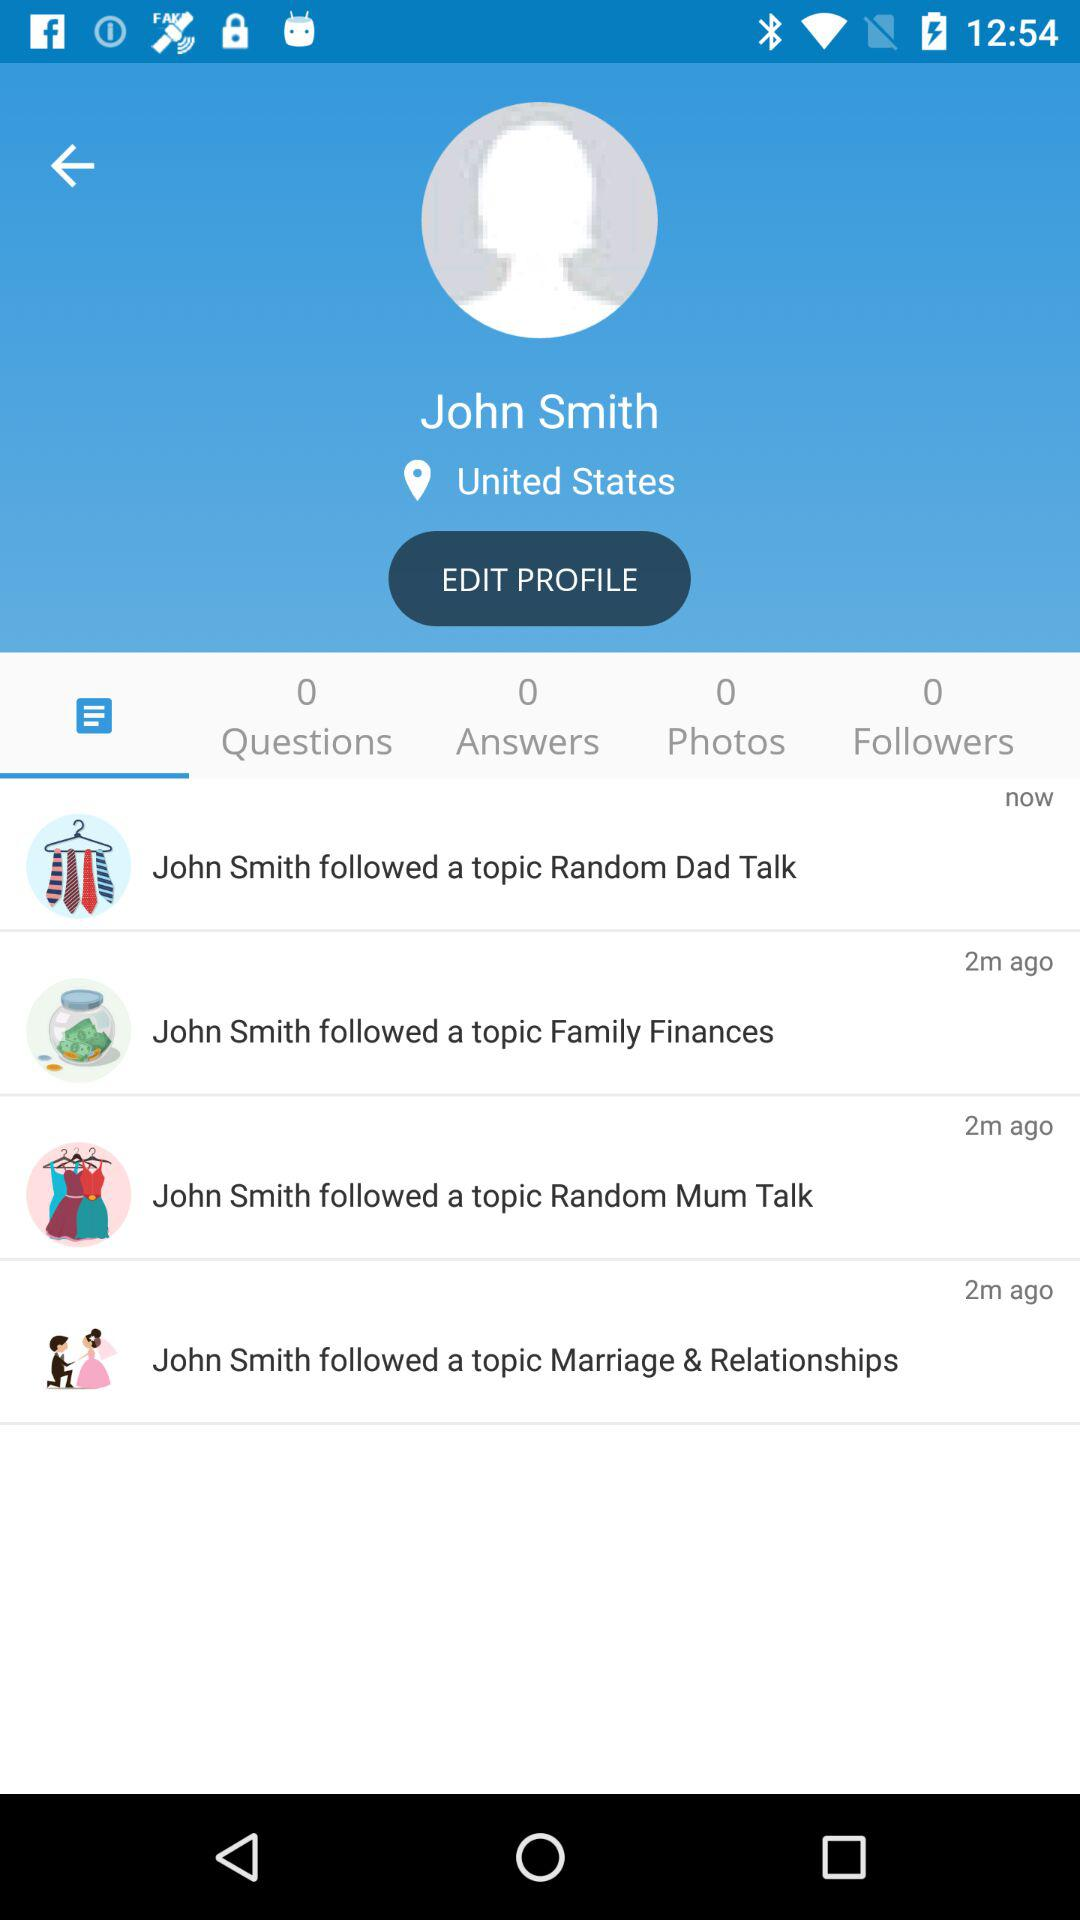How many topics did John Smith follow?
Answer the question using a single word or phrase. 4 